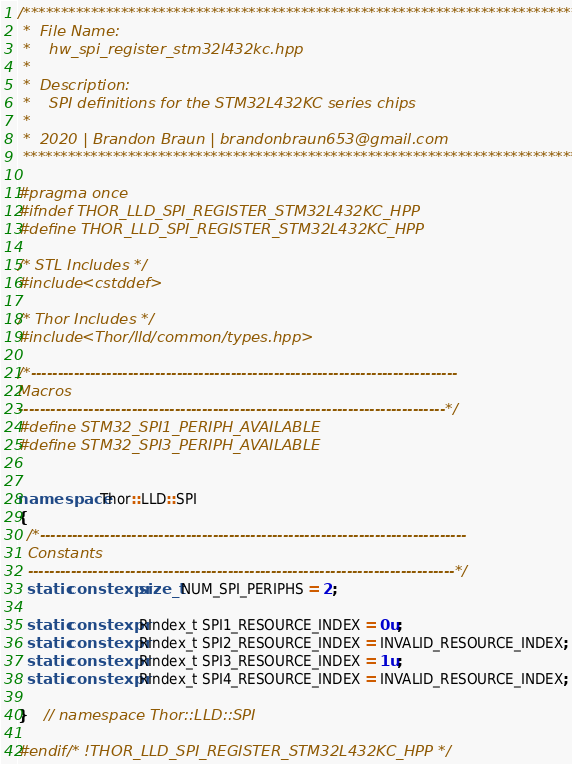Convert code to text. <code><loc_0><loc_0><loc_500><loc_500><_C++_>/********************************************************************************
 *  File Name:
 *    hw_spi_register_stm32l432kc.hpp
 *
 *  Description:
 *    SPI definitions for the STM32L432KC series chips
 *
 *  2020 | Brandon Braun | brandonbraun653@gmail.com
 *******************************************************************************/

#pragma once
#ifndef THOR_LLD_SPI_REGISTER_STM32L432KC_HPP
#define THOR_LLD_SPI_REGISTER_STM32L432KC_HPP

/* STL Includes */
#include <cstddef>

/* Thor Includes */
#include <Thor/lld/common/types.hpp>

/*-------------------------------------------------------------------------------
Macros
-------------------------------------------------------------------------------*/
#define STM32_SPI1_PERIPH_AVAILABLE
#define STM32_SPI3_PERIPH_AVAILABLE


namespace Thor::LLD::SPI
{
  /*-------------------------------------------------------------------------------
  Constants
  -------------------------------------------------------------------------------*/
  static constexpr size_t NUM_SPI_PERIPHS = 2;

  static constexpr RIndex_t SPI1_RESOURCE_INDEX = 0u;
  static constexpr RIndex_t SPI2_RESOURCE_INDEX = INVALID_RESOURCE_INDEX;
  static constexpr RIndex_t SPI3_RESOURCE_INDEX = 1u;
  static constexpr RIndex_t SPI4_RESOURCE_INDEX = INVALID_RESOURCE_INDEX;

}    // namespace Thor::LLD::SPI

#endif /* !THOR_LLD_SPI_REGISTER_STM32L432KC_HPP */
</code> 